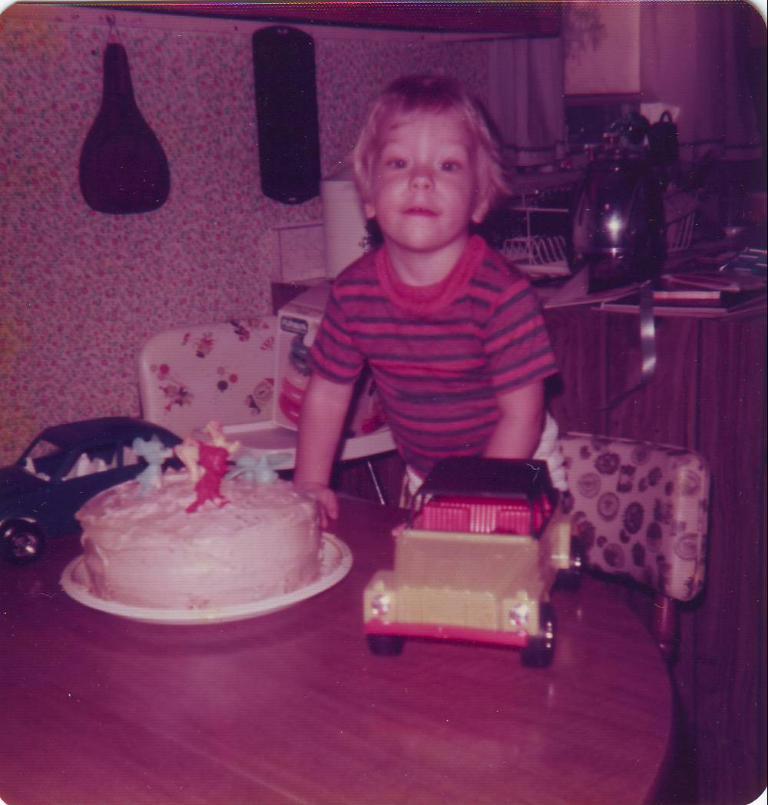Can you describe this image briefly? In this image there is a boy standing on the chair. In front of him there is a table. On top of it there is a cake. There are toys. Beside him there is a chair. On top of it there is some object. Behind him there is a table. On top of it there are a few objects. In the background of the image there are some objects on the wall. 